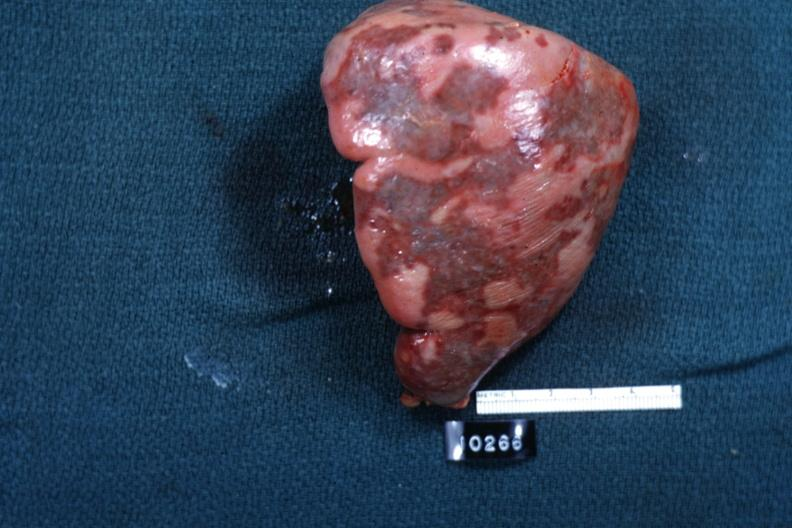what is external view of spleen with multiple recent infarcts cut?
Answer the question using a single word or phrase. Surface slide 